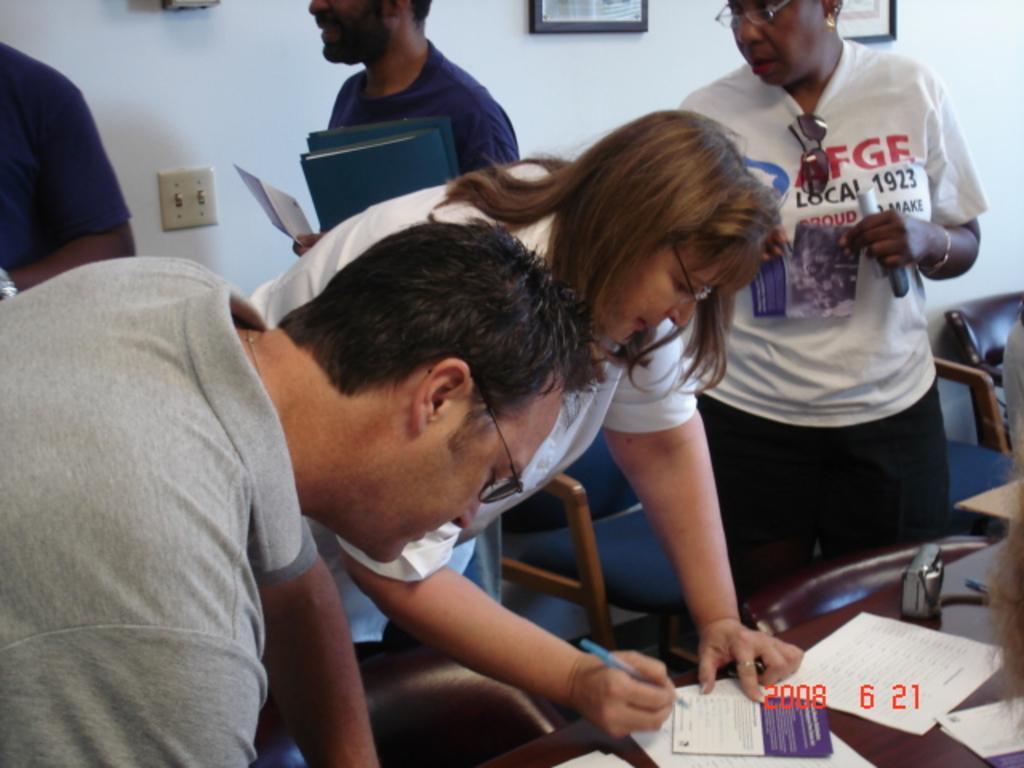How would you summarize this image in a sentence or two? As we can see in the image there are few people here and there, chairs, white color wall, photo frames and table. On table there are papers. 